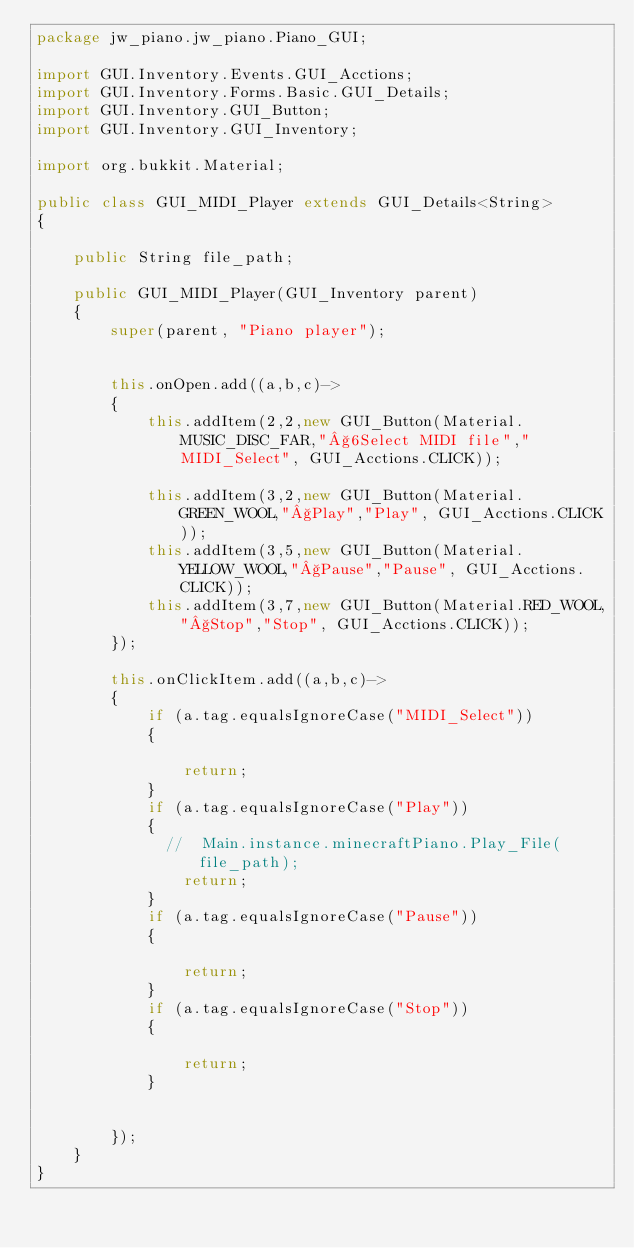<code> <loc_0><loc_0><loc_500><loc_500><_Java_>package jw_piano.jw_piano.Piano_GUI;

import GUI.Inventory.Events.GUI_Acctions;
import GUI.Inventory.Forms.Basic.GUI_Details;
import GUI.Inventory.GUI_Button;
import GUI.Inventory.GUI_Inventory;

import org.bukkit.Material;

public class GUI_MIDI_Player extends GUI_Details<String>
{

    public String file_path;

    public GUI_MIDI_Player(GUI_Inventory parent)
    {
        super(parent, "Piano player");


        this.onOpen.add((a,b,c)->
        {
            this.addItem(2,2,new GUI_Button(Material.MUSIC_DISC_FAR,"§6Select MIDI file","MIDI_Select", GUI_Acctions.CLICK));

            this.addItem(3,2,new GUI_Button(Material.GREEN_WOOL,"§Play","Play", GUI_Acctions.CLICK));
            this.addItem(3,5,new GUI_Button(Material.YELLOW_WOOL,"§Pause","Pause", GUI_Acctions.CLICK));
            this.addItem(3,7,new GUI_Button(Material.RED_WOOL,"§Stop","Stop", GUI_Acctions.CLICK));
        });

        this.onClickItem.add((a,b,c)->
        {
            if (a.tag.equalsIgnoreCase("MIDI_Select"))
            {

                return;
            }
            if (a.tag.equalsIgnoreCase("Play"))
            {
              //  Main.instance.minecraftPiano.Play_File(file_path);
                return;
            }
            if (a.tag.equalsIgnoreCase("Pause"))
            {

                return;
            }
            if (a.tag.equalsIgnoreCase("Stop"))
            {

                return;
            }


        });
    }
}
</code> 